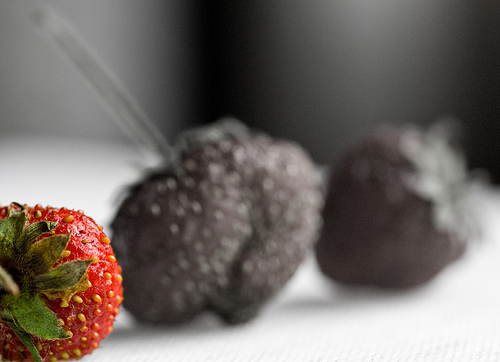<image>
Is there a table under the strawberry? Yes. The table is positioned underneath the strawberry, with the strawberry above it in the vertical space. 